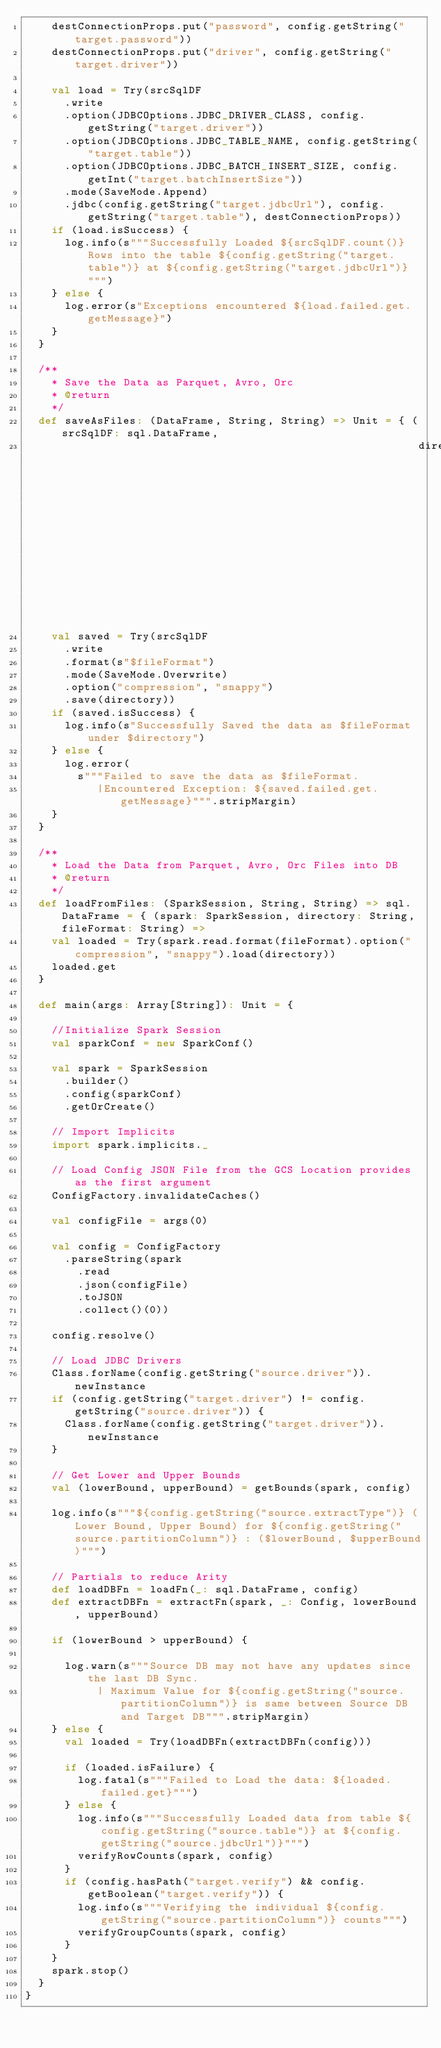Convert code to text. <code><loc_0><loc_0><loc_500><loc_500><_Scala_>    destConnectionProps.put("password", config.getString("target.password"))
    destConnectionProps.put("driver", config.getString("target.driver"))

    val load = Try(srcSqlDF
      .write
      .option(JDBCOptions.JDBC_DRIVER_CLASS, config.getString("target.driver"))
      .option(JDBCOptions.JDBC_TABLE_NAME, config.getString("target.table"))
      .option(JDBCOptions.JDBC_BATCH_INSERT_SIZE, config.getInt("target.batchInsertSize"))
      .mode(SaveMode.Append)
      .jdbc(config.getString("target.jdbcUrl"), config.getString("target.table"), destConnectionProps))
    if (load.isSuccess) {
      log.info(s"""Successfully Loaded ${srcSqlDF.count()} Rows into the table ${config.getString("target.table")} at ${config.getString("target.jdbcUrl")}""")
    } else {
      log.error(s"Exceptions encountered ${load.failed.get.getMessage}")
    }
  }

  /**
    * Save the Data as Parquet, Avro, Orc
    * @return
    */
  def saveAsFiles: (DataFrame, String, String) => Unit = { (srcSqlDF: sql.DataFrame,
                                                            directory: String, fileFormat: String) =>
    val saved = Try(srcSqlDF
      .write
      .format(s"$fileFormat")
      .mode(SaveMode.Overwrite)
      .option("compression", "snappy")
      .save(directory))
    if (saved.isSuccess) {
      log.info(s"Successfully Saved the data as $fileFormat under $directory")
    } else {
      log.error(
        s"""Failed to save the data as $fileFormat.
           |Encountered Exception: ${saved.failed.get.getMessage}""".stripMargin)
    }
  }

  /**
    * Load the Data from Parquet, Avro, Orc Files into DB
    * @return
    */
  def loadFromFiles: (SparkSession, String, String) => sql.DataFrame = { (spark: SparkSession, directory: String, fileFormat: String) =>
    val loaded = Try(spark.read.format(fileFormat).option("compression", "snappy").load(directory))
    loaded.get
  }

  def main(args: Array[String]): Unit = {

    //Initialize Spark Session
    val sparkConf = new SparkConf()

    val spark = SparkSession
      .builder()
      .config(sparkConf)
      .getOrCreate()

    // Import Implicits
    import spark.implicits._

    // Load Config JSON File from the GCS Location provides as the first argument
    ConfigFactory.invalidateCaches()

    val configFile = args(0)

    val config = ConfigFactory
      .parseString(spark
        .read
        .json(configFile)
        .toJSON
        .collect()(0))

    config.resolve()

    // Load JDBC Drivers
    Class.forName(config.getString("source.driver")).newInstance
    if (config.getString("target.driver") != config.getString("source.driver")) {
      Class.forName(config.getString("target.driver")).newInstance
    }

    // Get Lower and Upper Bounds
    val (lowerBound, upperBound) = getBounds(spark, config)

    log.info(s"""${config.getString("source.extractType")} (Lower Bound, Upper Bound) for ${config.getString("source.partitionColumn")} : ($lowerBound, $upperBound)""")

    // Partials to reduce Arity
    def loadDBFn = loadFn(_: sql.DataFrame, config)
    def extractDBFn = extractFn(spark, _: Config, lowerBound, upperBound)

    if (lowerBound > upperBound) {

      log.warn(s"""Source DB may not have any updates since the last DB Sync.
           | Maximum Value for ${config.getString("source.partitionColumn")} is same between Source DB and Target DB""".stripMargin)
    } else {
      val loaded = Try(loadDBFn(extractDBFn(config)))

      if (loaded.isFailure) {
        log.fatal(s"""Failed to Load the data: ${loaded.failed.get}""")
      } else {
        log.info(s"""Successfully Loaded data from table ${config.getString("source.table")} at ${config.getString("source.jdbcUrl")}""")
        verifyRowCounts(spark, config)
      }
      if (config.hasPath("target.verify") && config.getBoolean("target.verify")) {
        log.info(s"""Verifying the individual ${config.getString("source.partitionColumn")} counts""")
        verifyGroupCounts(spark, config)
      }
    }
    spark.stop()
  }
}
</code> 